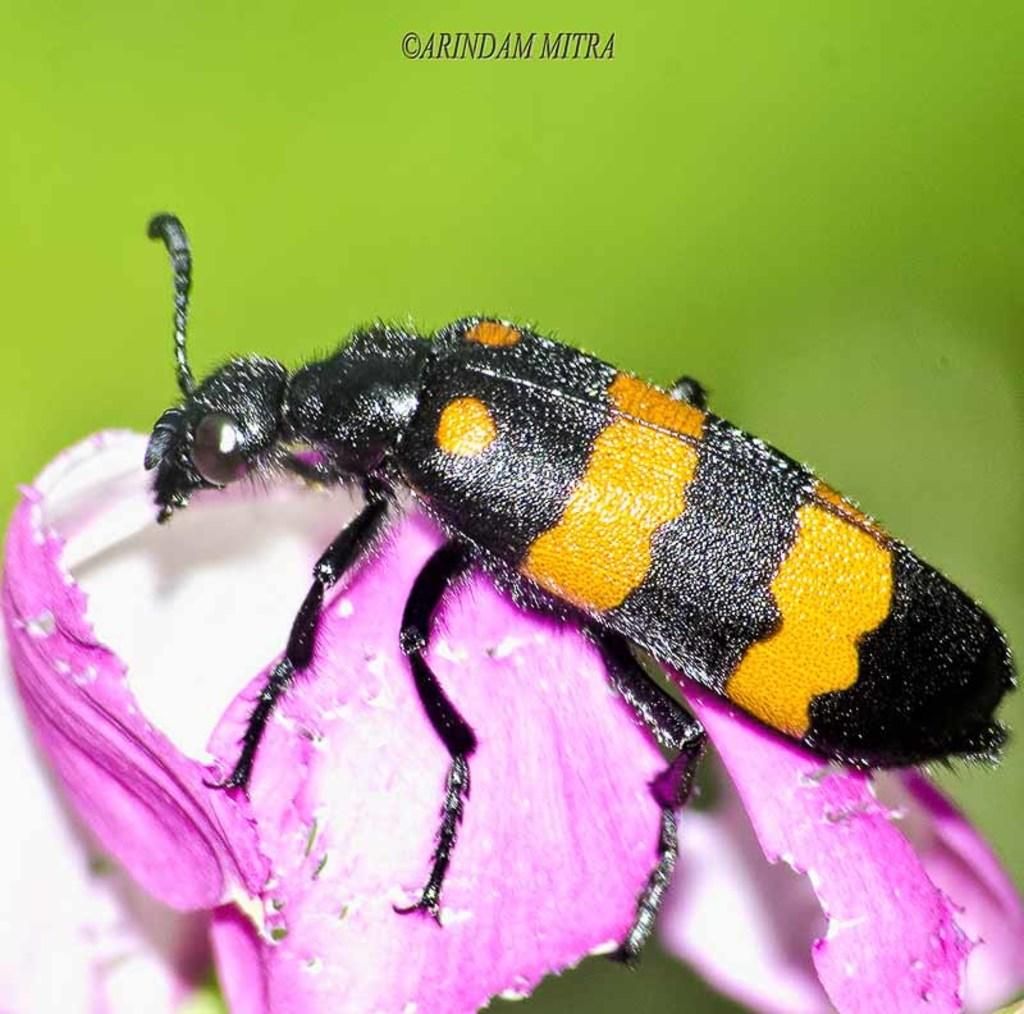What type of creature can be seen in the image? There is an insect in the image. Where is the insect located? The insect is on a flower. What type of insurance policy is the insect holding in the image? There is no insurance policy present in the image, as it features an insect on a flower. 